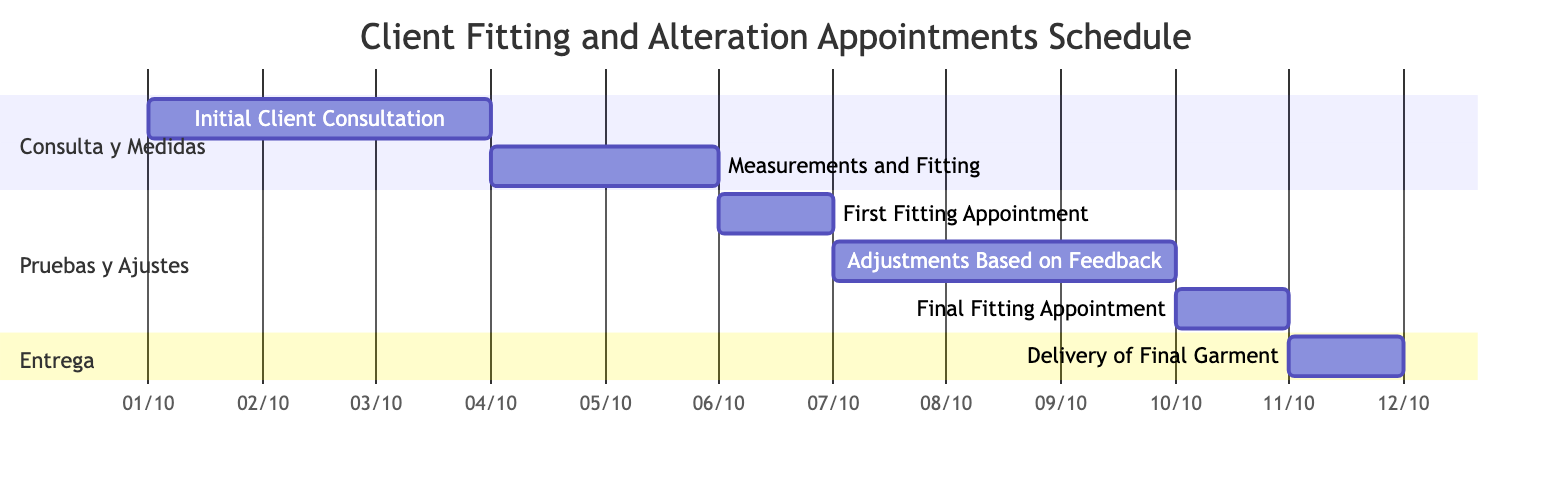What is the duration of the Initial Client Consultation? The diagram specifies the duration for the Initial Client Consultation task as 3 days. This is indicated next to the task in the Gantt chart.
Answer: 3 days When does the First Fitting Appointment start? The start date for the First Fitting Appointment is shown in the diagram as October 6, 2023, which is clearly marked beside the task.
Answer: October 6, 2023 How many days are allocated for Adjustments Based on Feedback? The diagram indicates that the Adjustments Based on Feedback task lasts for 3 days, which is displayed next to this task in the Gantt chart.
Answer: 3 days Which task is scheduled immediately after the Measurements and Fitting? The diagram shows that the First Fitting Appointment follows directly after the Measurements and Fitting, as it starts on October 6, which is the day after the end of the Measurements and Fitting.
Answer: First Fitting Appointment What is the end date of the Delivery of Final Garment task? The end date for the Delivery of Final Garment is clearly indicated in the diagram as October 11, 2023, which is marked next to this task.
Answer: October 11, 2023 Which two tasks have the same duration of 1 day? The tasks that both have a duration of 1 day, as indicated in the diagram, are the First Fitting Appointment and the Final Fitting Appointment.
Answer: First Fitting Appointment and Final Fitting Appointment What is the time gap between the First Fitting Appointment and the Final Fitting Appointment? The diagram shows that the First Fitting Appointment ends on October 6 and the Final Fitting Appointment starts on October 10. This results in a 3-day gap between these two tasks.
Answer: 3 days How many total tasks are scheduled in the Gantt Chart? The diagram lists a total of 6 tasks within the schedule, which can be counted directly from the chart.
Answer: 6 tasks What section does the Final Fitting Appointment belong to? The Final Fitting Appointment is part of the "Pruebas y Ajustes" section, as indicated by its positioning within that category in the Gantt chart.
Answer: Pruebas y Ajustes 